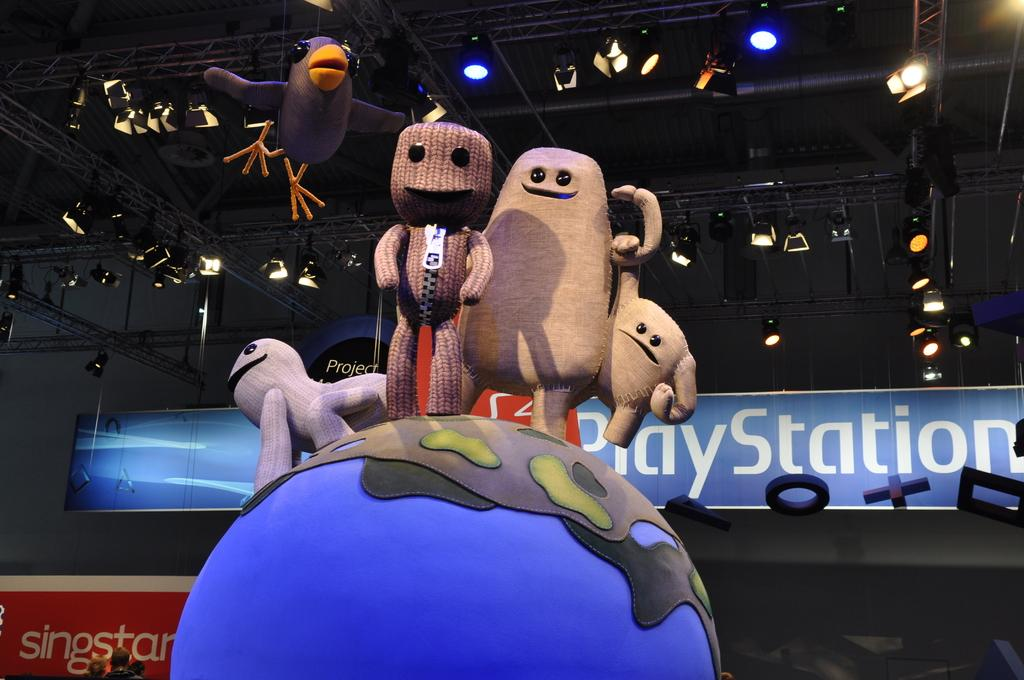What objects can be seen in the image? There are toys in the image. Where are some of the toys located? Some toys are on a globe. What can be seen in the background of the image? There are people, boards, lights, and rods in the background of the image. What type of frame is used to hold the sugar in the image? There is no sugar or frame present in the image. How many bricks are visible in the image? There are no bricks visible in the image. 